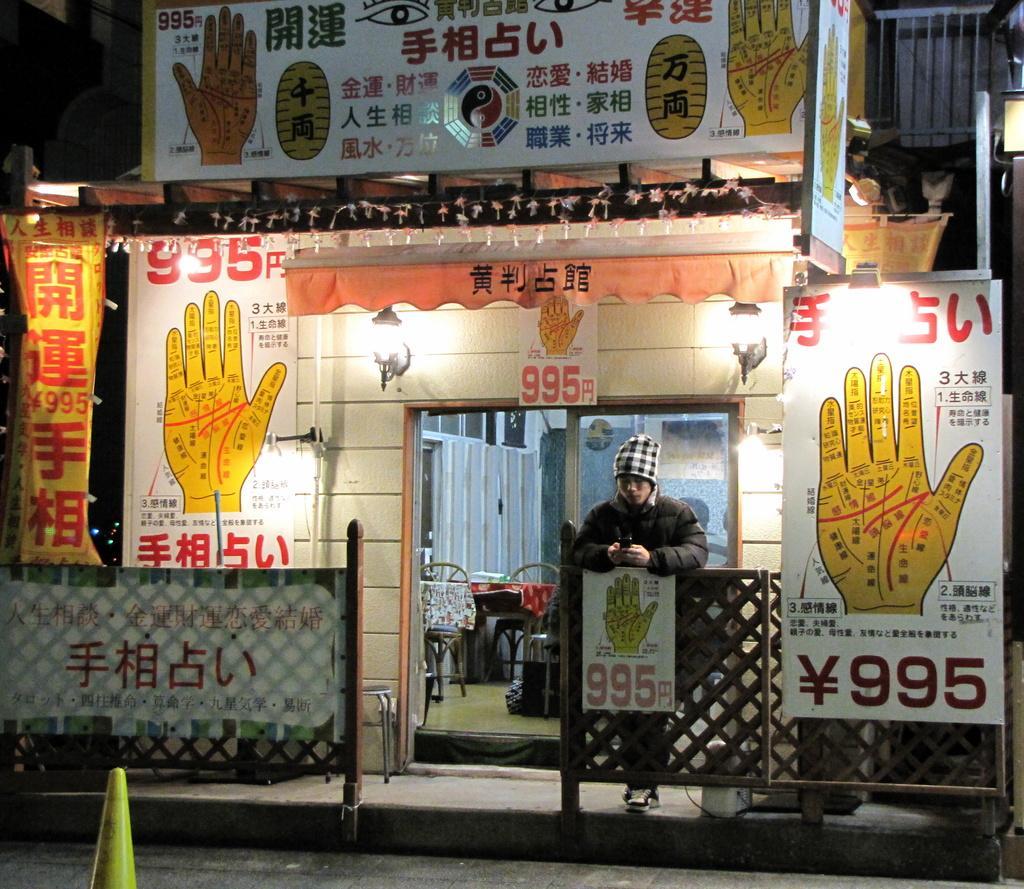Can you describe this image briefly? In this image there is a road, in the background there is a shop, for that shop there are poster, on that posters there is some text and a person is standing in front of a shop. 